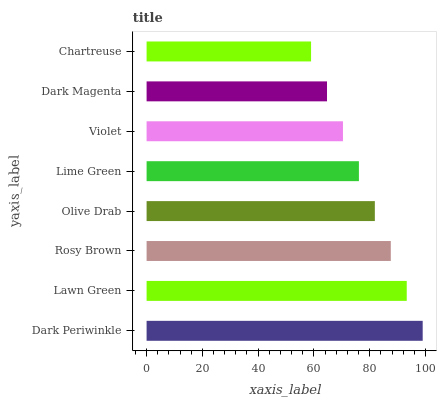Is Chartreuse the minimum?
Answer yes or no. Yes. Is Dark Periwinkle the maximum?
Answer yes or no. Yes. Is Lawn Green the minimum?
Answer yes or no. No. Is Lawn Green the maximum?
Answer yes or no. No. Is Dark Periwinkle greater than Lawn Green?
Answer yes or no. Yes. Is Lawn Green less than Dark Periwinkle?
Answer yes or no. Yes. Is Lawn Green greater than Dark Periwinkle?
Answer yes or no. No. Is Dark Periwinkle less than Lawn Green?
Answer yes or no. No. Is Olive Drab the high median?
Answer yes or no. Yes. Is Lime Green the low median?
Answer yes or no. Yes. Is Dark Magenta the high median?
Answer yes or no. No. Is Chartreuse the low median?
Answer yes or no. No. 